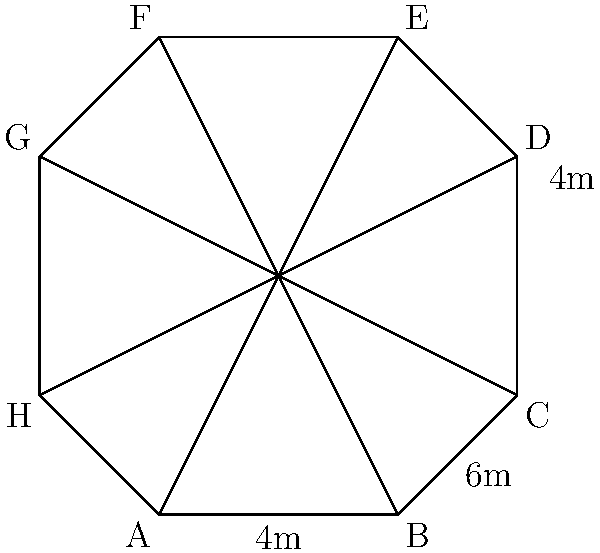Your local union has decided to build an octagonal meeting hall. The hall's shape is a regular octagon with diagonals of 8 meters connecting opposite corners. If the short side of the octagon is 4 meters, what is the total area of the meeting hall in square meters? Let's approach this step-by-step:

1) In a regular octagon, we can divide it into 8 congruent triangles by drawing lines from the center to each vertex.

2) The area of the octagon will be 8 times the area of one of these triangles.

3) Each triangle has a base of 4 meters (the short side of the octagon) and a height that we need to calculate.

4) The diagonal of the octagon (8 meters) is twice the height of our triangle.

5) So, the height of each triangle is 4 meters.

6) The area of one triangle is:
   $A_{triangle} = \frac{1}{2} \times base \times height = \frac{1}{2} \times 4 \times 4 = 8$ sq meters

7) The total area of the octagon is:
   $A_{octagon} = 8 \times A_{triangle} = 8 \times 8 = 64$ sq meters

Therefore, the total area of the union meeting hall is 64 square meters.
Answer: 64 sq meters 